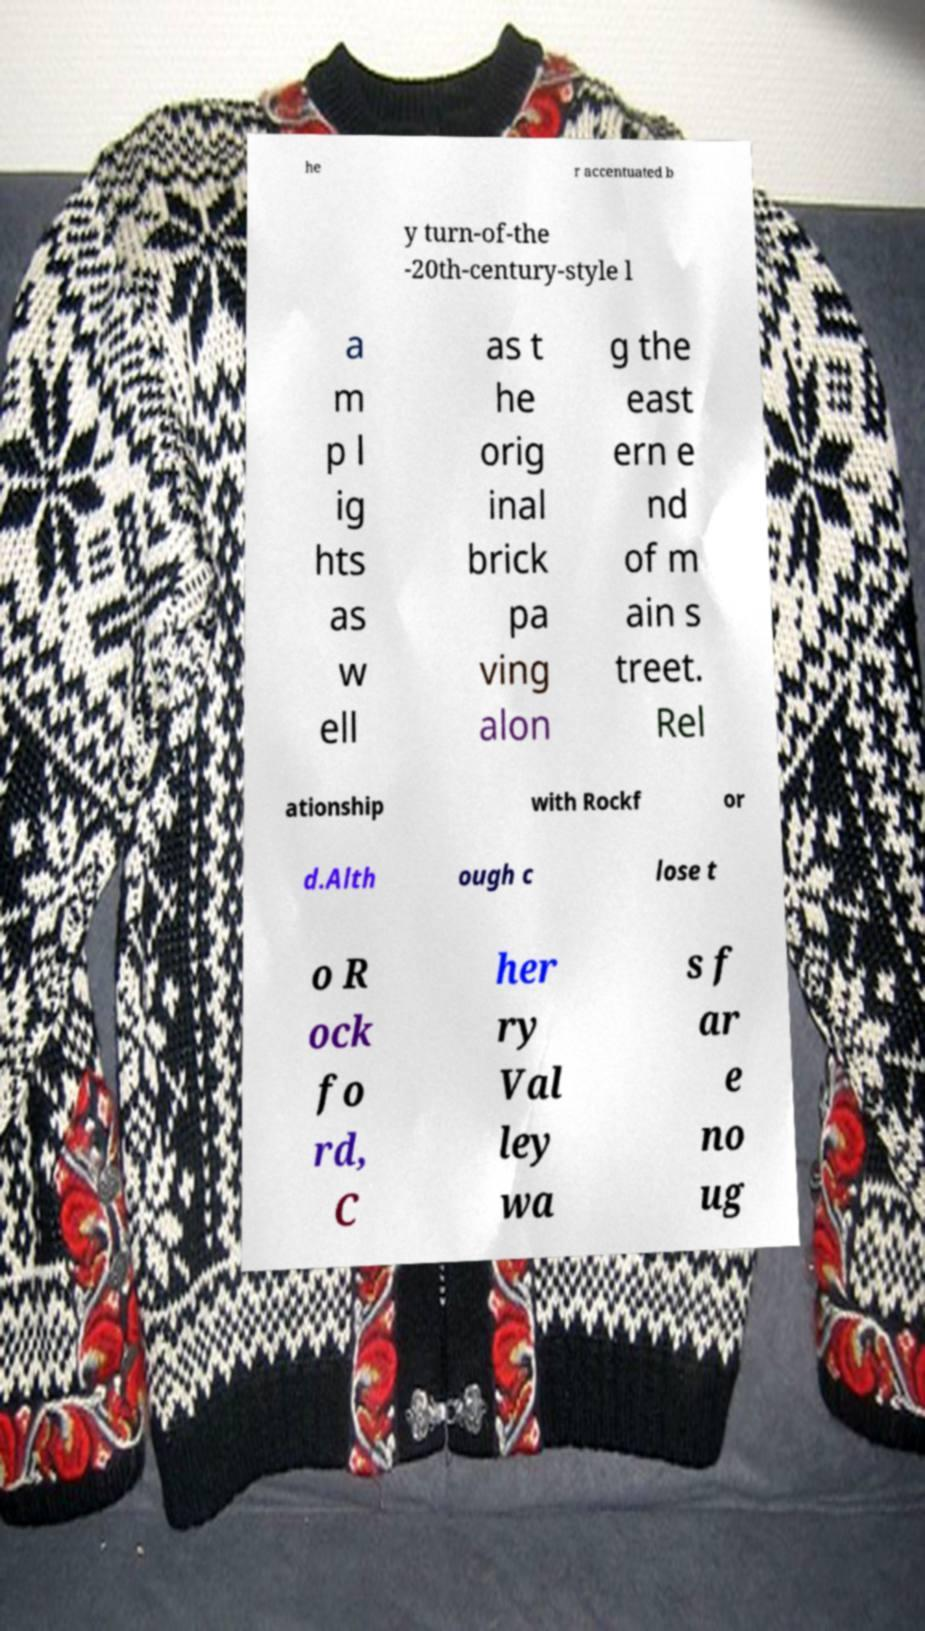Please identify and transcribe the text found in this image. he r accentuated b y turn-of-the -20th-century-style l a m p l ig hts as w ell as t he orig inal brick pa ving alon g the east ern e nd of m ain s treet. Rel ationship with Rockf or d.Alth ough c lose t o R ock fo rd, C her ry Val ley wa s f ar e no ug 